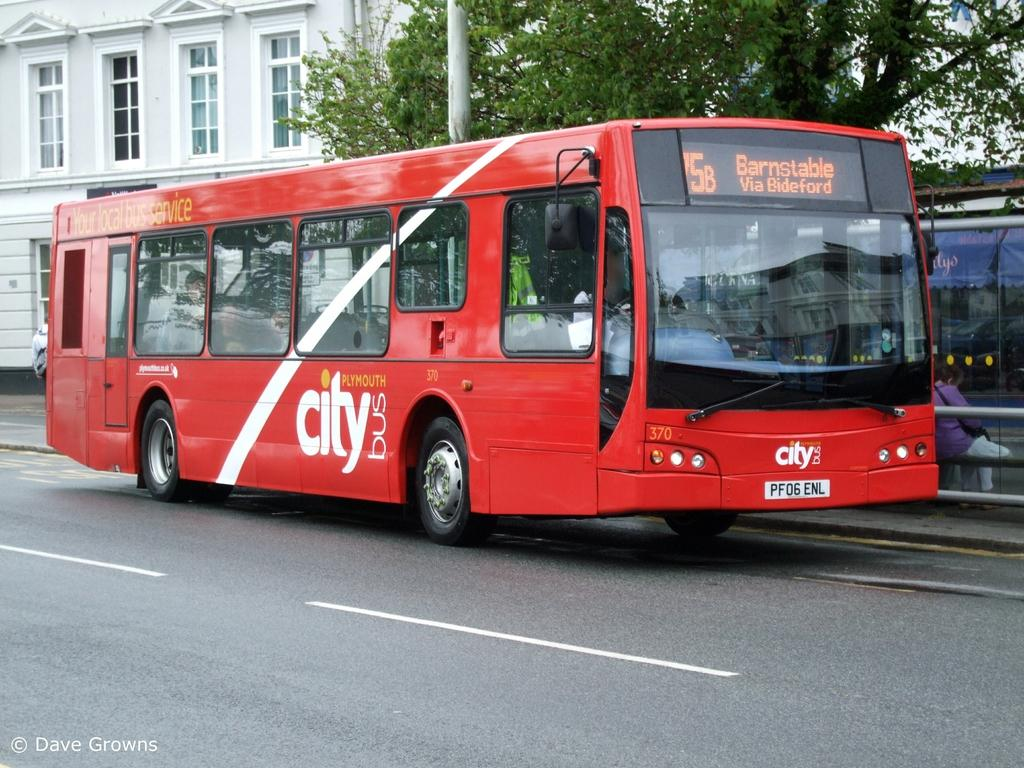<image>
Describe the image concisely. A red City Bus with the destination Barnstable. 